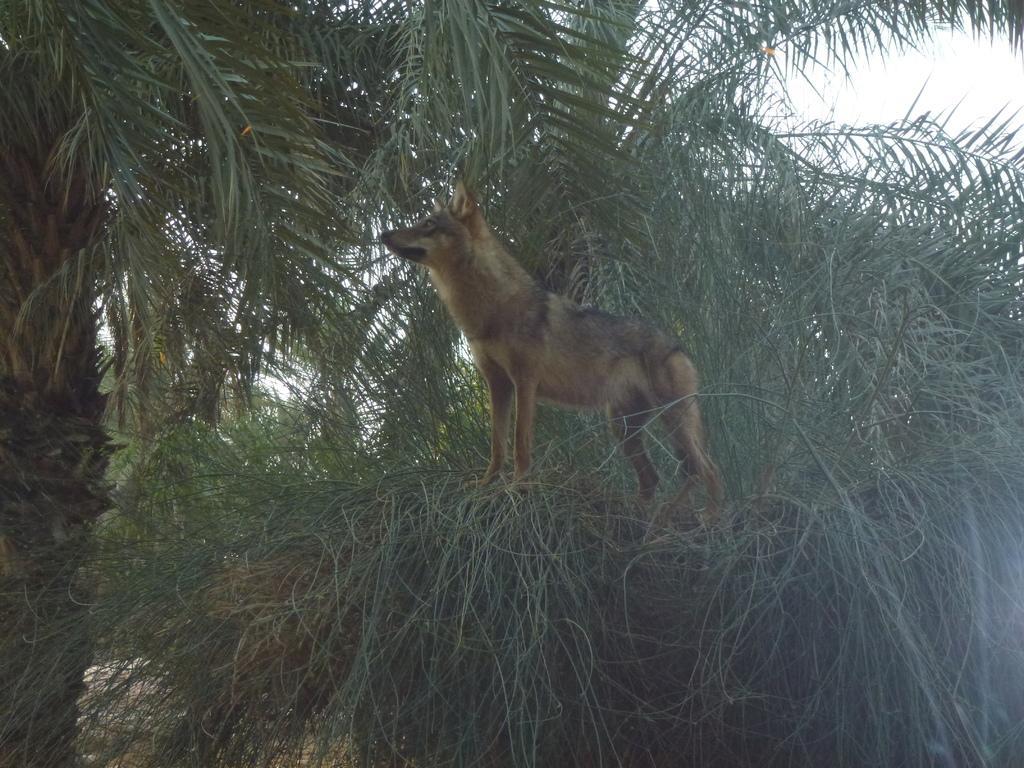Describe this image in one or two sentences. In this image I can see a brown colour dog. In the background I can see number of trees. 